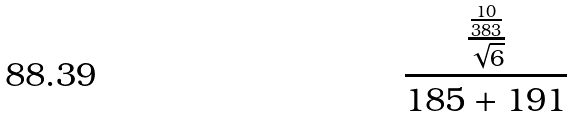Convert formula to latex. <formula><loc_0><loc_0><loc_500><loc_500>\frac { \frac { \frac { 1 0 } { 3 8 3 } } { \sqrt { 6 } } } { 1 8 5 + 1 9 1 }</formula> 